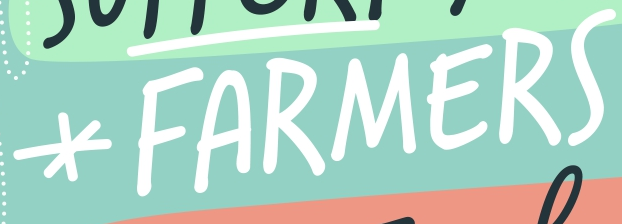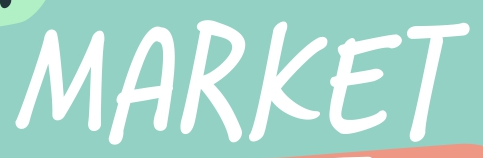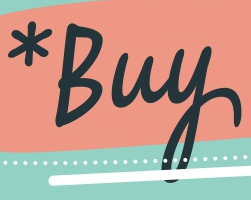Read the text content from these images in order, separated by a semicolon. *FARMERS; MARKET; *Buy 